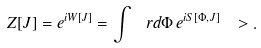<formula> <loc_0><loc_0><loc_500><loc_500>Z [ J ] = e ^ { i W [ J ] } = \int \ r d \Phi \, e ^ { i S [ \Phi , J ] } \ > .</formula> 